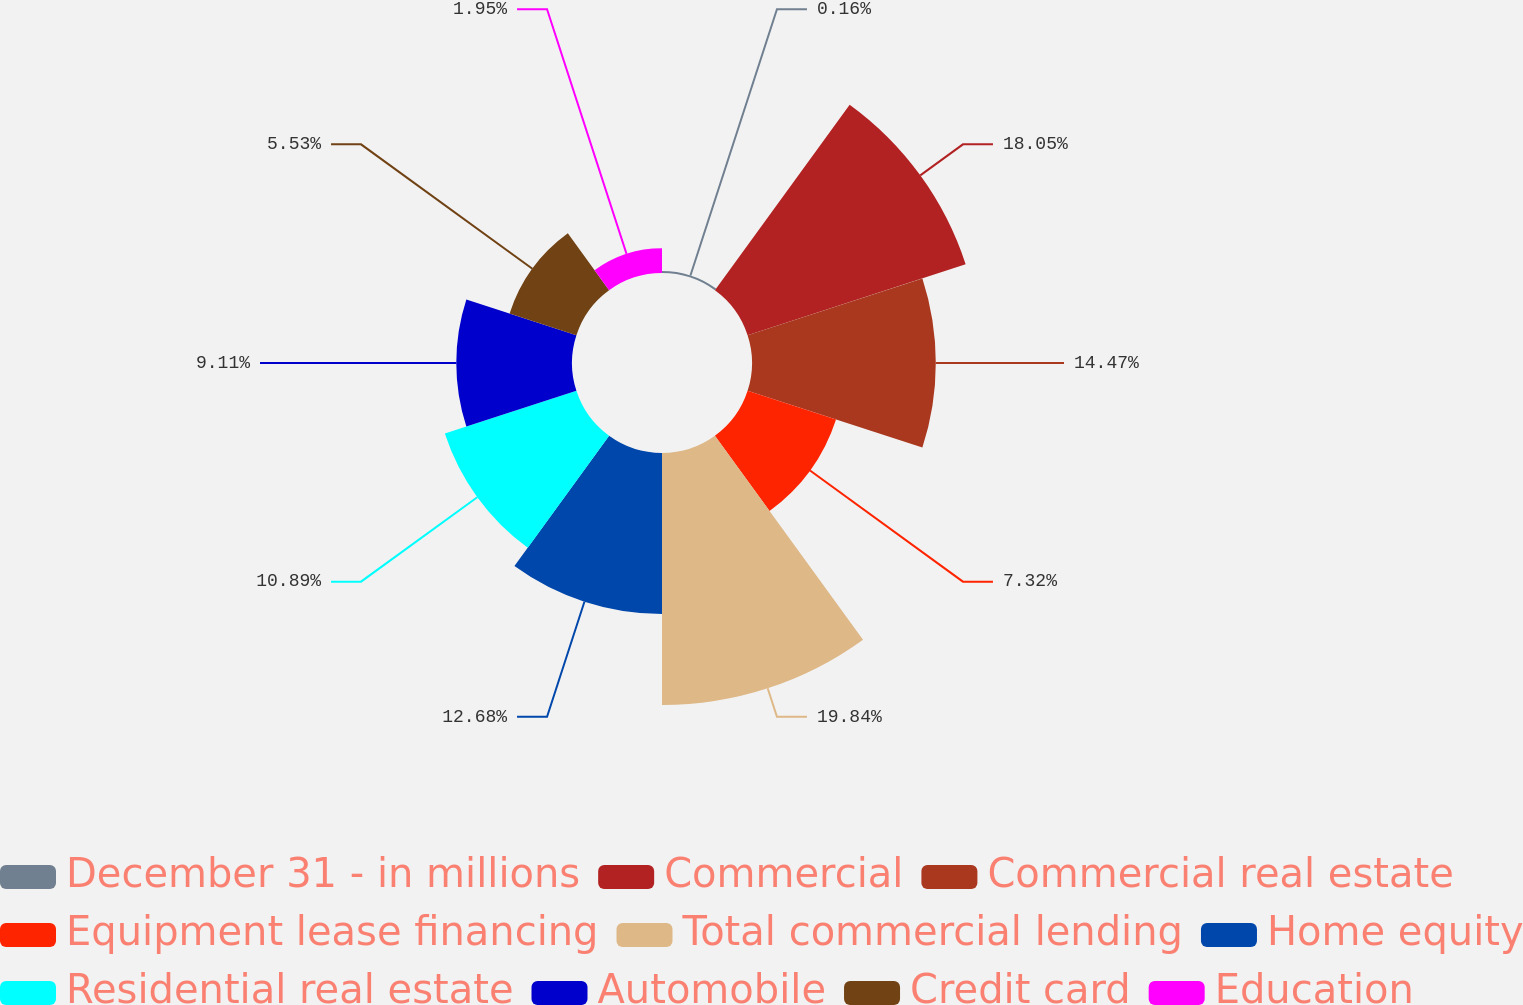Convert chart to OTSL. <chart><loc_0><loc_0><loc_500><loc_500><pie_chart><fcel>December 31 - in millions<fcel>Commercial<fcel>Commercial real estate<fcel>Equipment lease financing<fcel>Total commercial lending<fcel>Home equity<fcel>Residential real estate<fcel>Automobile<fcel>Credit card<fcel>Education<nl><fcel>0.16%<fcel>18.05%<fcel>14.47%<fcel>7.32%<fcel>19.84%<fcel>12.68%<fcel>10.89%<fcel>9.11%<fcel>5.53%<fcel>1.95%<nl></chart> 